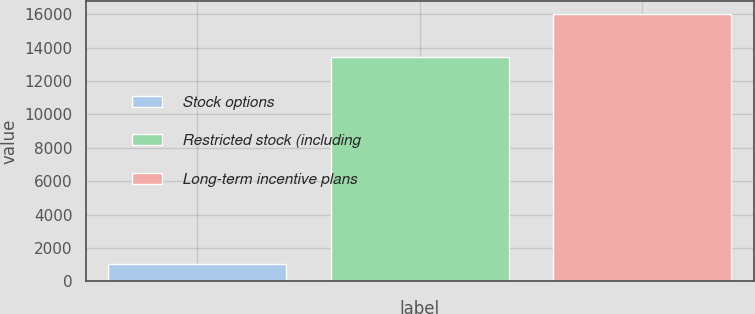<chart> <loc_0><loc_0><loc_500><loc_500><bar_chart><fcel>Stock options<fcel>Restricted stock (including<fcel>Long-term incentive plans<nl><fcel>1056<fcel>13418<fcel>16006<nl></chart> 